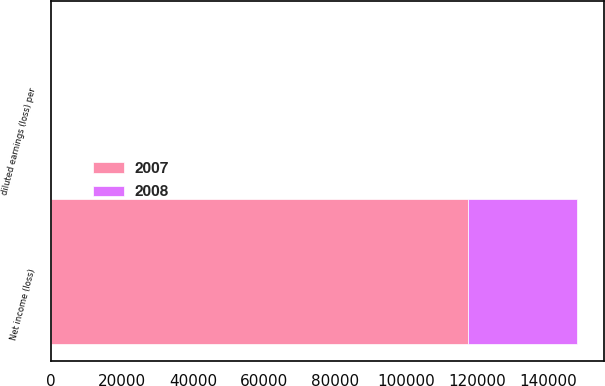Convert chart to OTSL. <chart><loc_0><loc_0><loc_500><loc_500><stacked_bar_chart><ecel><fcel>Net income (loss)<fcel>diluted earnings (loss) per<nl><fcel>2007<fcel>117361<fcel>1.88<nl><fcel>2008<fcel>30803<fcel>0.45<nl></chart> 